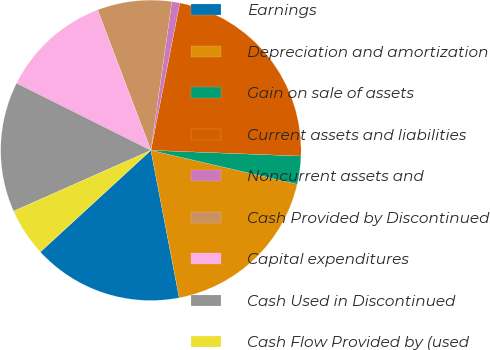<chart> <loc_0><loc_0><loc_500><loc_500><pie_chart><fcel>Earnings<fcel>Depreciation and amortization<fcel>Gain on sale of assets<fcel>Current assets and liabilities<fcel>Noncurrent assets and<fcel>Cash Provided by Discontinued<fcel>Capital expenditures<fcel>Cash Used in Discontinued<fcel>Cash Flow Provided by (used<nl><fcel>16.19%<fcel>18.35%<fcel>3.02%<fcel>22.52%<fcel>0.86%<fcel>8.0%<fcel>11.85%<fcel>14.02%<fcel>5.19%<nl></chart> 